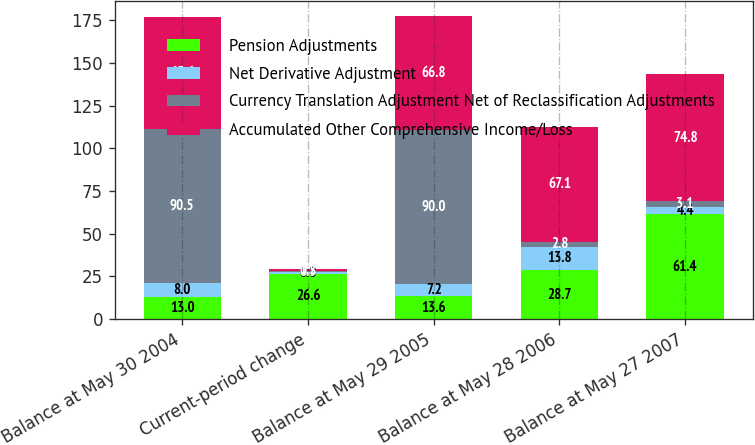<chart> <loc_0><loc_0><loc_500><loc_500><stacked_bar_chart><ecel><fcel>Balance at May 30 2004<fcel>Current-period change<fcel>Balance at May 29 2005<fcel>Balance at May 28 2006<fcel>Balance at May 27 2007<nl><fcel>Pension Adjustments<fcel>13<fcel>26.6<fcel>13.6<fcel>28.7<fcel>61.4<nl><fcel>Net Derivative Adjustment<fcel>8<fcel>0.8<fcel>7.2<fcel>13.8<fcel>4.4<nl><fcel>Currency Translation Adjustment Net of Reclassification Adjustments<fcel>90.5<fcel>0.5<fcel>90<fcel>2.8<fcel>3.1<nl><fcel>Accumulated Other Comprehensive Income/Loss<fcel>65.6<fcel>1.2<fcel>66.8<fcel>67.1<fcel>74.8<nl></chart> 